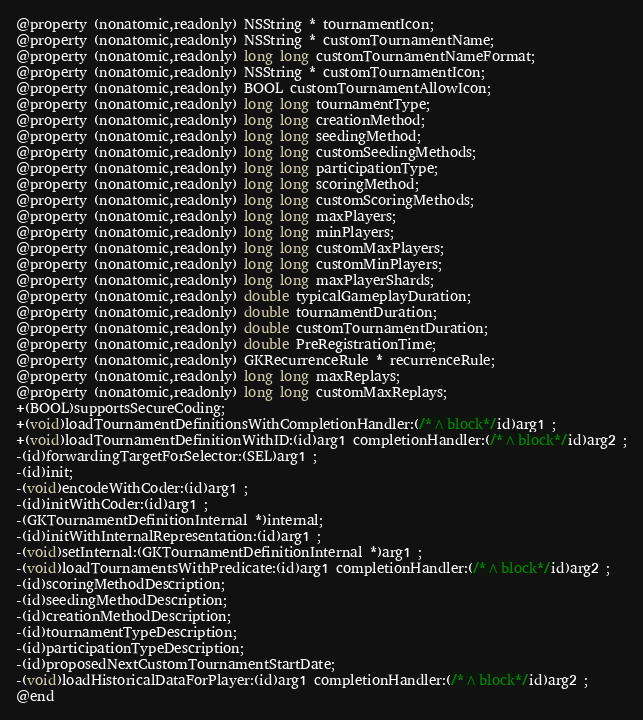Convert code to text. <code><loc_0><loc_0><loc_500><loc_500><_C_>@property (nonatomic,readonly) NSString * tournamentIcon; 
@property (nonatomic,readonly) NSString * customTournamentName; 
@property (nonatomic,readonly) long long customTournamentNameFormat; 
@property (nonatomic,readonly) NSString * customTournamentIcon; 
@property (nonatomic,readonly) BOOL customTournamentAllowIcon; 
@property (nonatomic,readonly) long long tournamentType; 
@property (nonatomic,readonly) long long creationMethod; 
@property (nonatomic,readonly) long long seedingMethod; 
@property (nonatomic,readonly) long long customSeedingMethods; 
@property (nonatomic,readonly) long long participationType; 
@property (nonatomic,readonly) long long scoringMethod; 
@property (nonatomic,readonly) long long customScoringMethods; 
@property (nonatomic,readonly) long long maxPlayers; 
@property (nonatomic,readonly) long long minPlayers; 
@property (nonatomic,readonly) long long customMaxPlayers; 
@property (nonatomic,readonly) long long customMinPlayers; 
@property (nonatomic,readonly) long long maxPlayerShards; 
@property (nonatomic,readonly) double typicalGameplayDuration; 
@property (nonatomic,readonly) double tournamentDuration; 
@property (nonatomic,readonly) double customTournamentDuration; 
@property (nonatomic,readonly) double PreRegistrationTime; 
@property (nonatomic,readonly) GKRecurrenceRule * recurrenceRule; 
@property (nonatomic,readonly) long long maxReplays; 
@property (nonatomic,readonly) long long customMaxReplays; 
+(BOOL)supportsSecureCoding;
+(void)loadTournamentDefinitionsWithCompletionHandler:(/*^block*/id)arg1 ;
+(void)loadTournamentDefinitionWithID:(id)arg1 completionHandler:(/*^block*/id)arg2 ;
-(id)forwardingTargetForSelector:(SEL)arg1 ;
-(id)init;
-(void)encodeWithCoder:(id)arg1 ;
-(id)initWithCoder:(id)arg1 ;
-(GKTournamentDefinitionInternal *)internal;
-(id)initWithInternalRepresentation:(id)arg1 ;
-(void)setInternal:(GKTournamentDefinitionInternal *)arg1 ;
-(void)loadTournamentsWithPredicate:(id)arg1 completionHandler:(/*^block*/id)arg2 ;
-(id)scoringMethodDescription;
-(id)seedingMethodDescription;
-(id)creationMethodDescription;
-(id)tournamentTypeDescription;
-(id)participationTypeDescription;
-(id)proposedNextCustomTournamentStartDate;
-(void)loadHistoricalDataForPlayer:(id)arg1 completionHandler:(/*^block*/id)arg2 ;
@end

</code> 